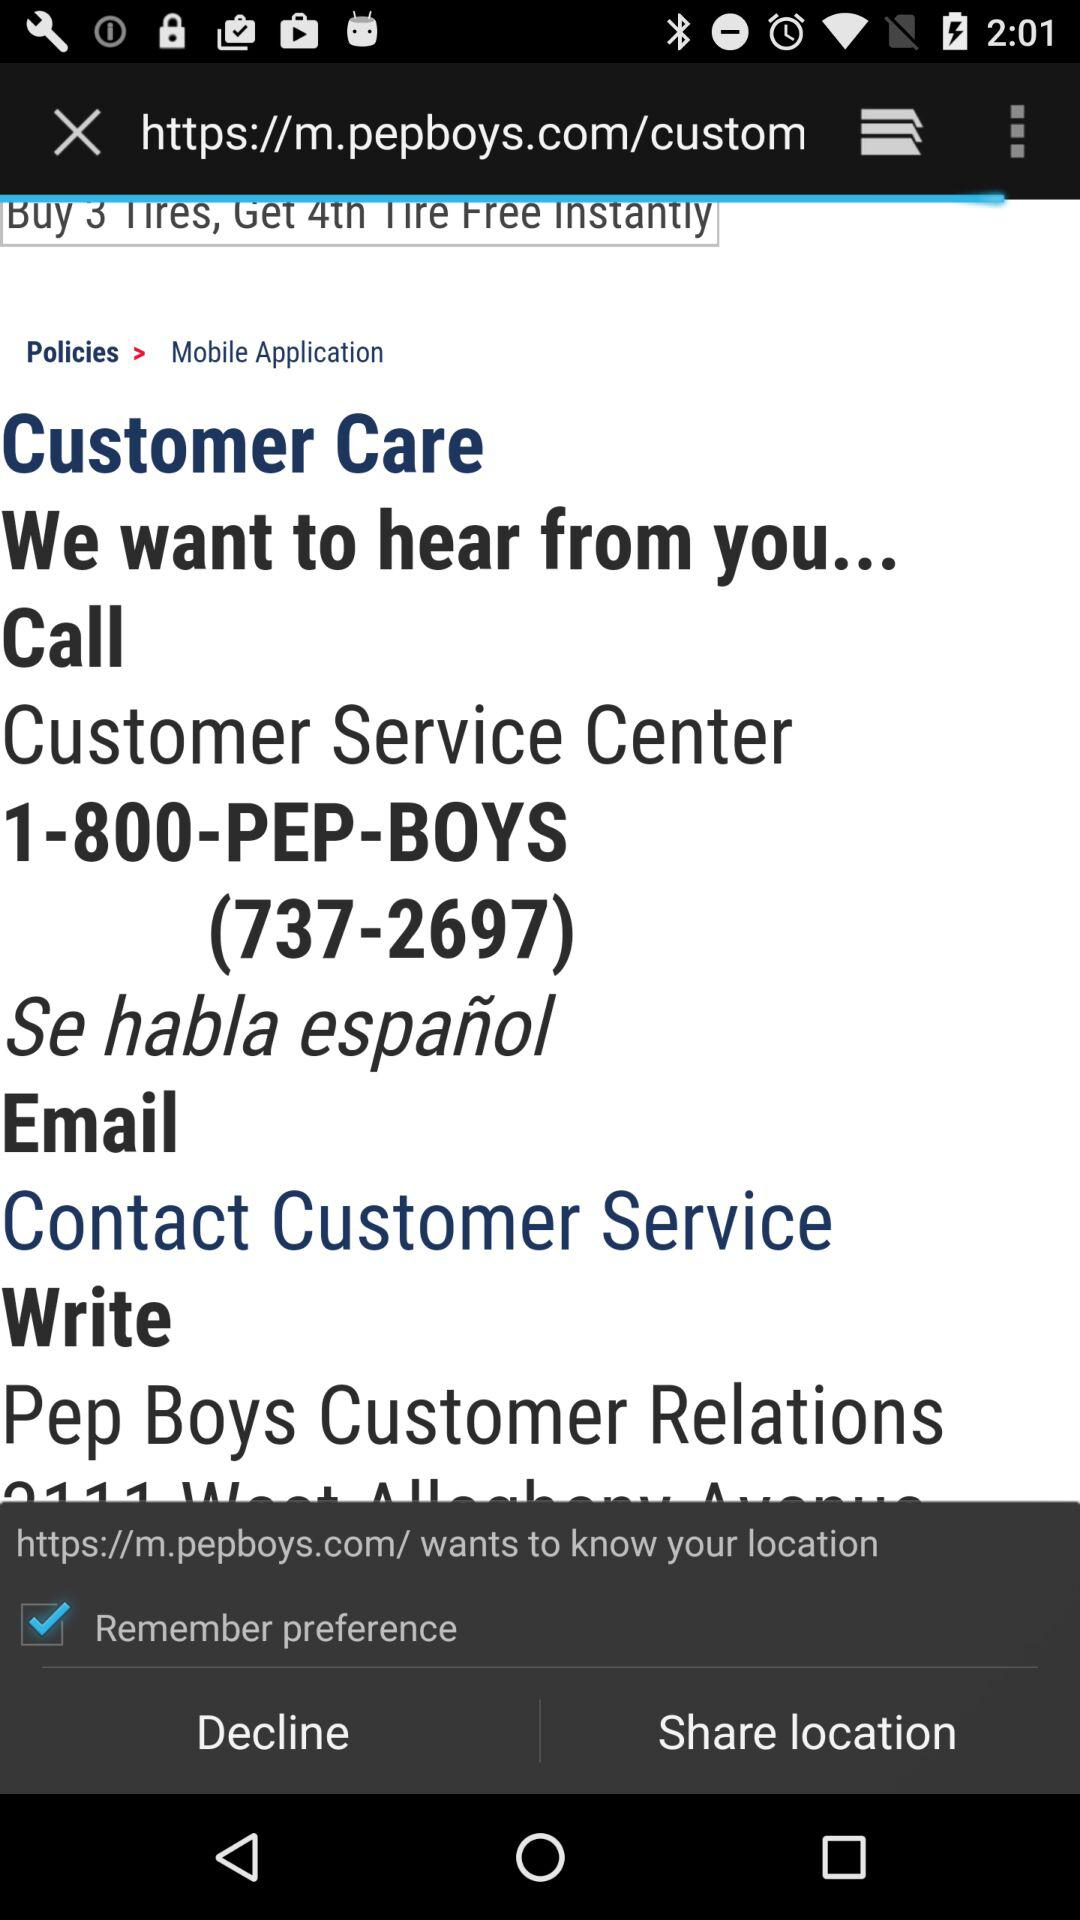What is the status of "Remember preference"? The status is "on". 